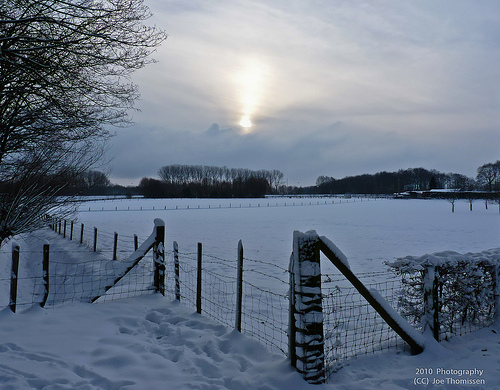<image>
Can you confirm if the sky is under the tree? No. The sky is not positioned under the tree. The vertical relationship between these objects is different. Is there a fence post to the right of the corner brace? No. The fence post is not to the right of the corner brace. The horizontal positioning shows a different relationship. 